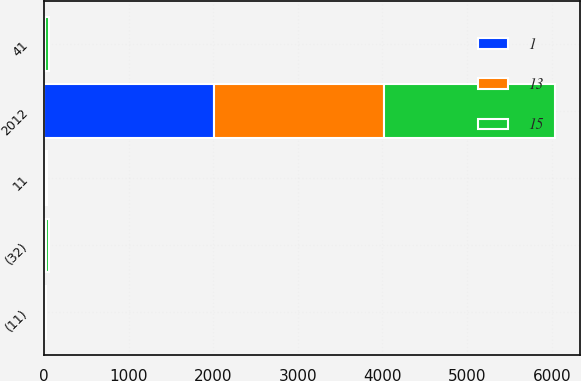<chart> <loc_0><loc_0><loc_500><loc_500><stacked_bar_chart><ecel><fcel>2012<fcel>(32)<fcel>41<fcel>11<fcel>(11)<nl><fcel>1<fcel>2012<fcel>14<fcel>14<fcel>28<fcel>13<nl><fcel>15<fcel>2011<fcel>40<fcel>39<fcel>1<fcel>1<nl><fcel>13<fcel>2011<fcel>4<fcel>1<fcel>5<fcel>15<nl></chart> 